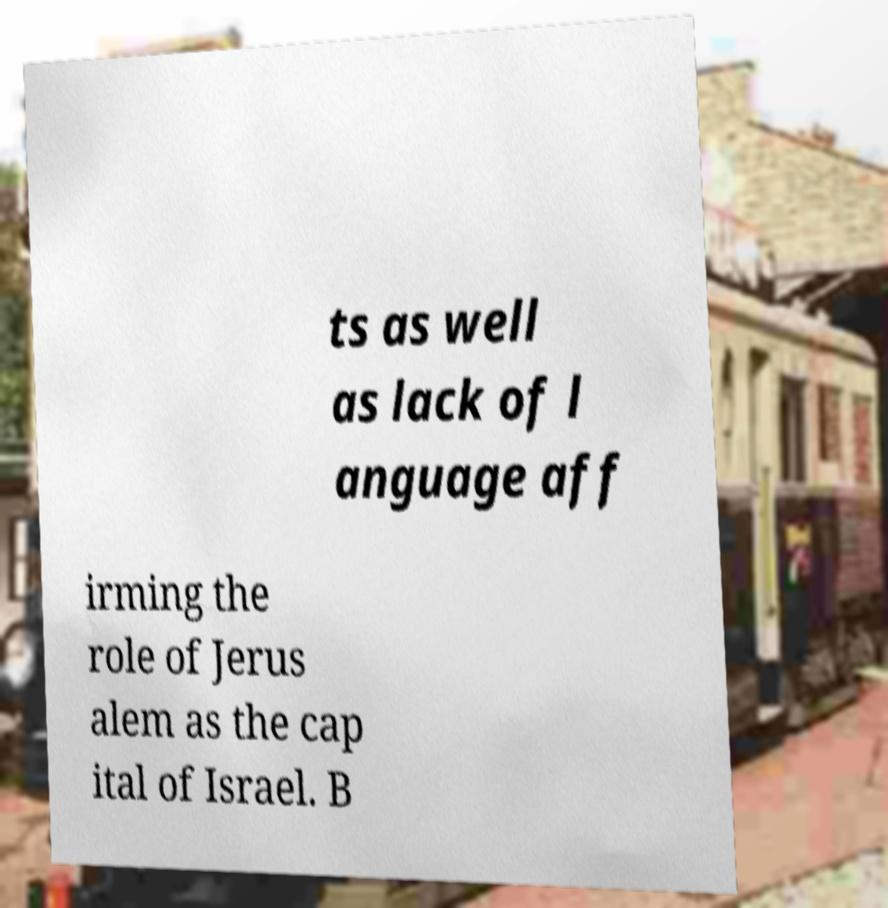Please read and relay the text visible in this image. What does it say? ts as well as lack of l anguage aff irming the role of Jerus alem as the cap ital of Israel. B 